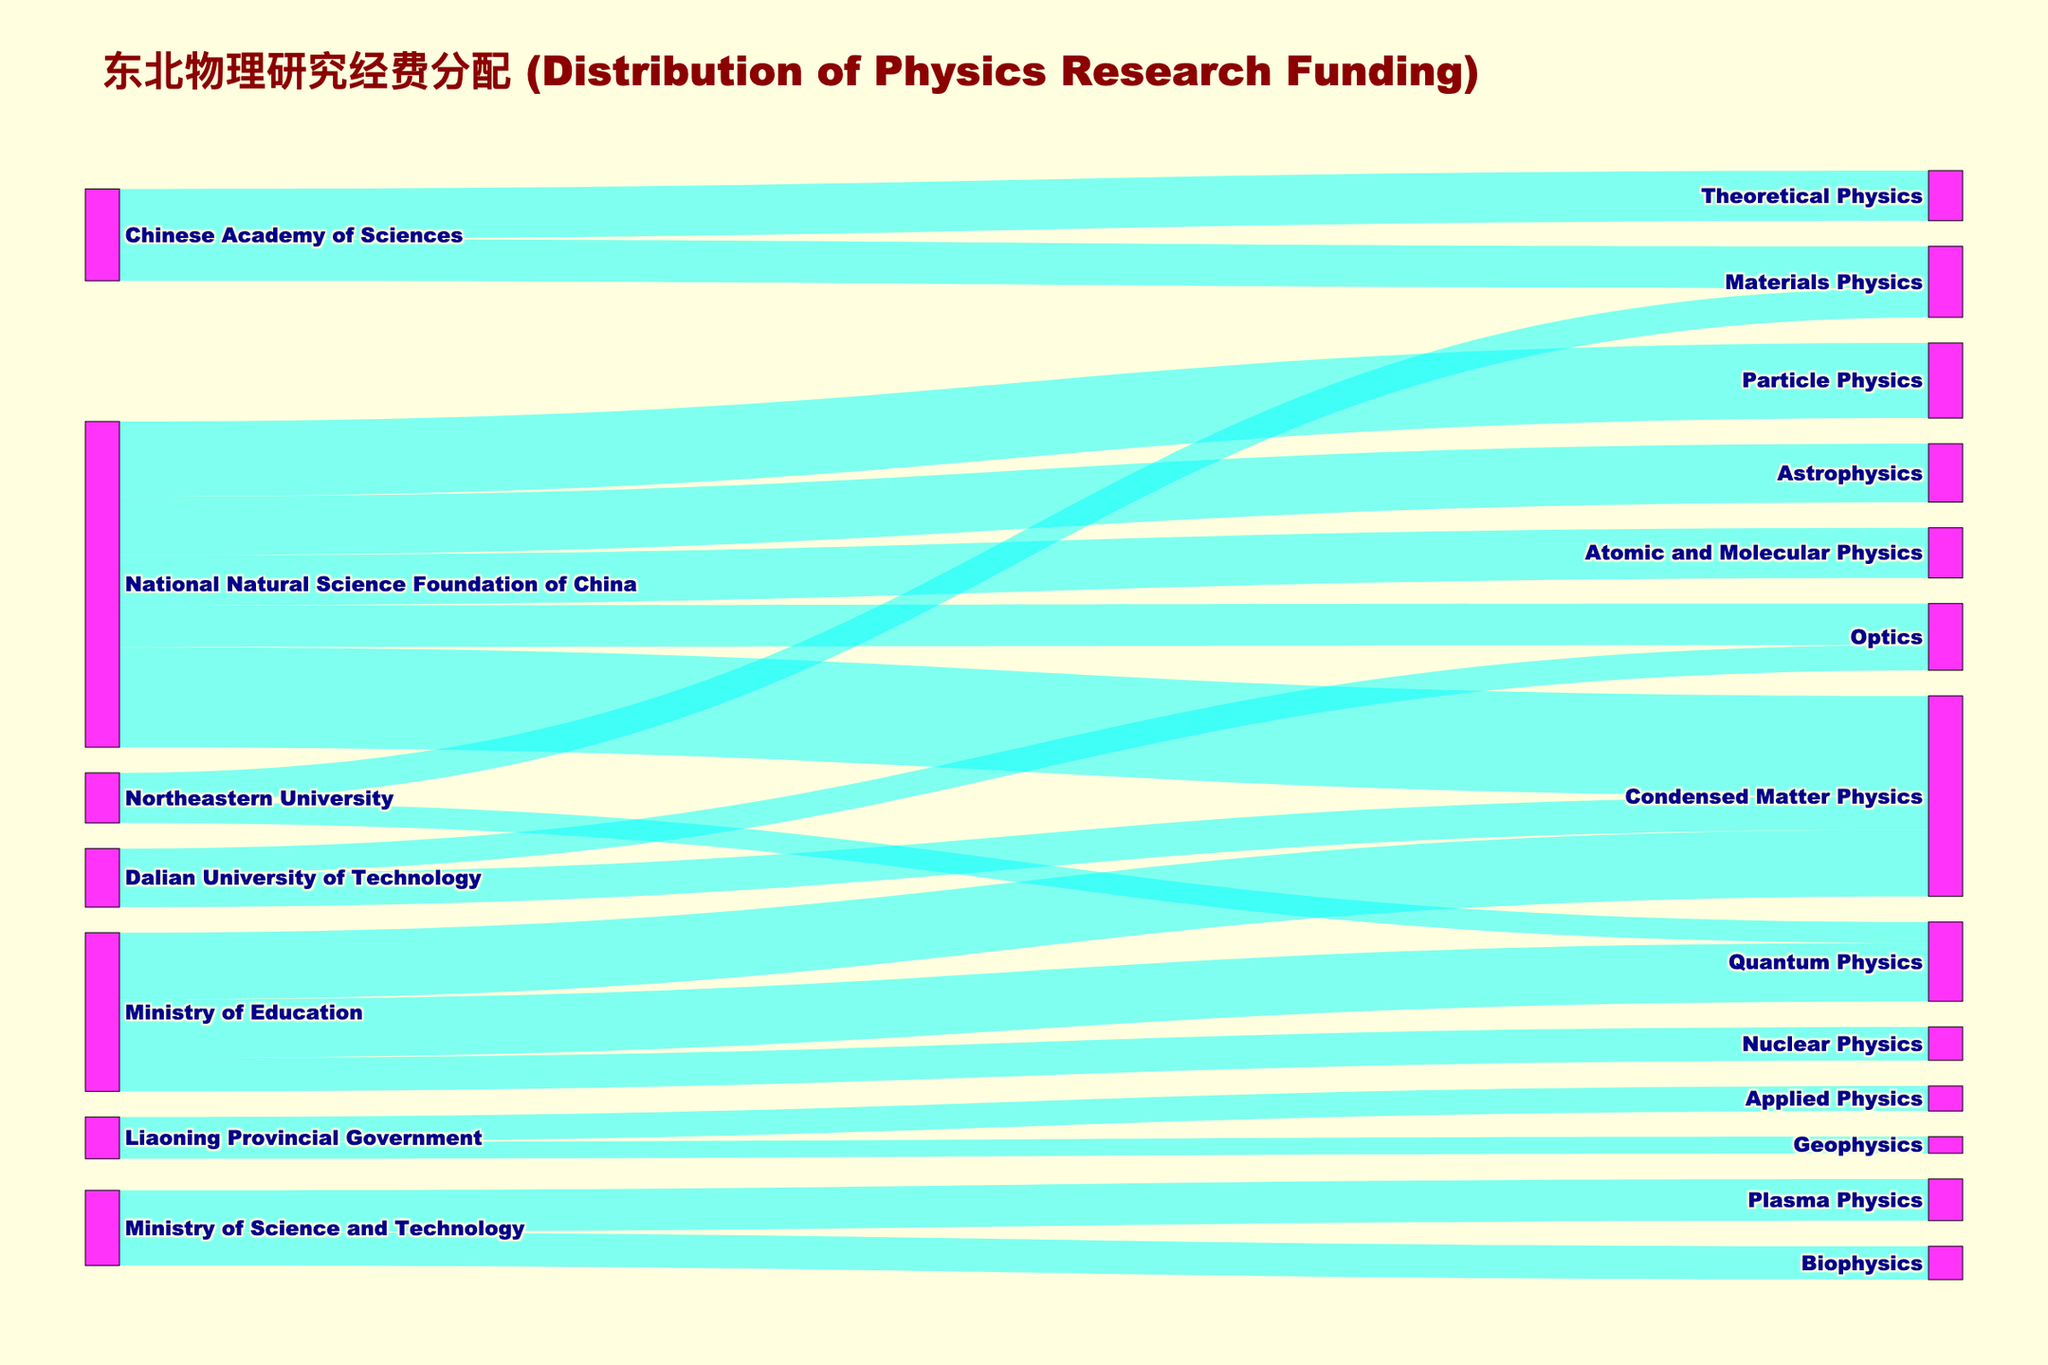What's the title of the Sankey diagram? The title is displayed at the top of the Sankey diagram in larger, colored text.
Answer: "东北物理研究经费分配 (Distribution of Physics Research Funding)" Which subfield received the most funding from the National Natural Science Foundation of China? By examining the links originating from "National Natural Science Foundation of China," identify the link with the highest value.
Answer: Condensed Matter Physics How many subfields does the Ministry of Education fund? Count the number of distinct targets connected to "Ministry of Education."
Answer: 3 What is the total research funding received by Condensed Matter Physics from all sources? Sum the values for all links targeting "Condensed Matter Physics."
Answer: 240 Which funding organization supports the highest number of different subfields? Compare the distinct targets for each source and identify the one with the most.
Answer: National Natural Science Foundation of China Between Quantum Physics and Nuclear Physics, which subfield receives more funding from the Ministry of Education? Compare the values of links originating from "Ministry of Education" and targeting "Quantum Physics" and "Nuclear Physics."
Answer: Quantum Physics What is the combined funding for Biophysics and Plasma Physics? Sum the values for the links targeting "Biophysics" and "Plasma Physics."
Answer: 90 Which university provides funding for Materials Physics? Identify the sources for "Materials Physics" in the Sankey diagram.
Answer: Northeastern University How does the funding amount from the Chinese Academy of Sciences to Theoretical Physics compare to that to Materials Physics? Compare the link values from "Chinese Academy of Sciences" to both "Theoretical Physics" and "Materials Physics."
Answer: Theoretical Physics and Materials Physics receive equal funding List the subfields funded by Liaoning Provincial Government. Identify all targets connected to "Liaoning Provincial Government."
Answer: Applied Physics, Geophysics 